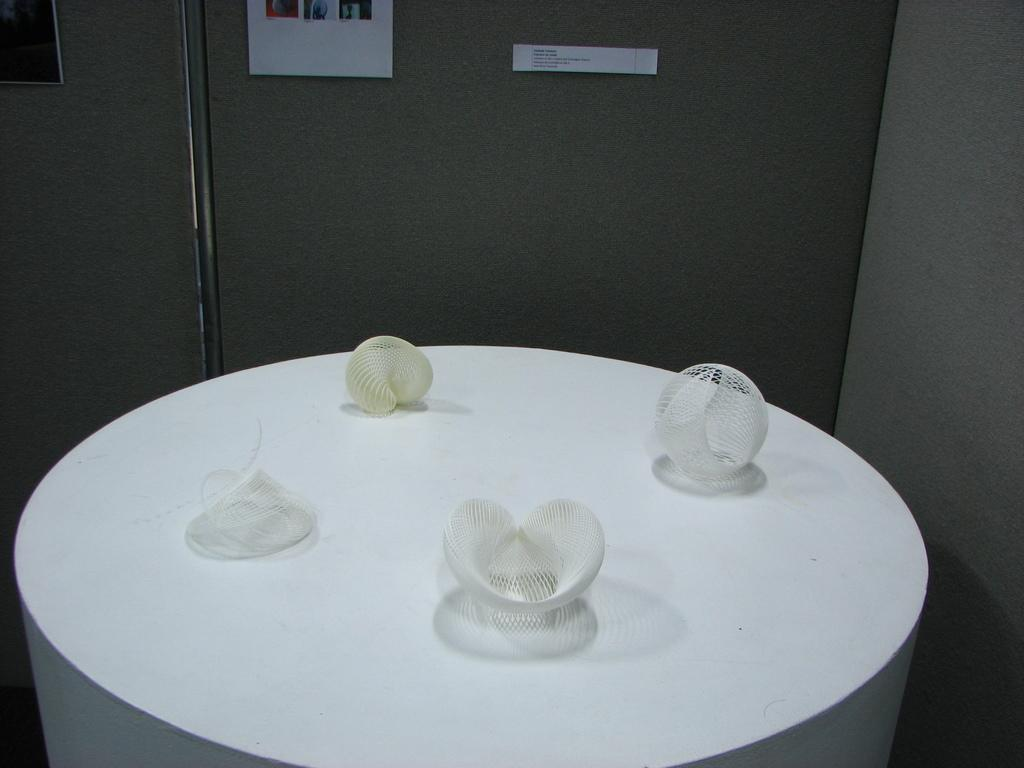What is the color of the table in the image? The table in the image is white. How many objects are on the table? There are four different objects on the table. What can be seen on the right side of the table? There is a wall on the right side of the table. What type of drum can be heard playing in the background of the image? There is no drum or sound present in the image; it is a still image of a white table with objects on it. 